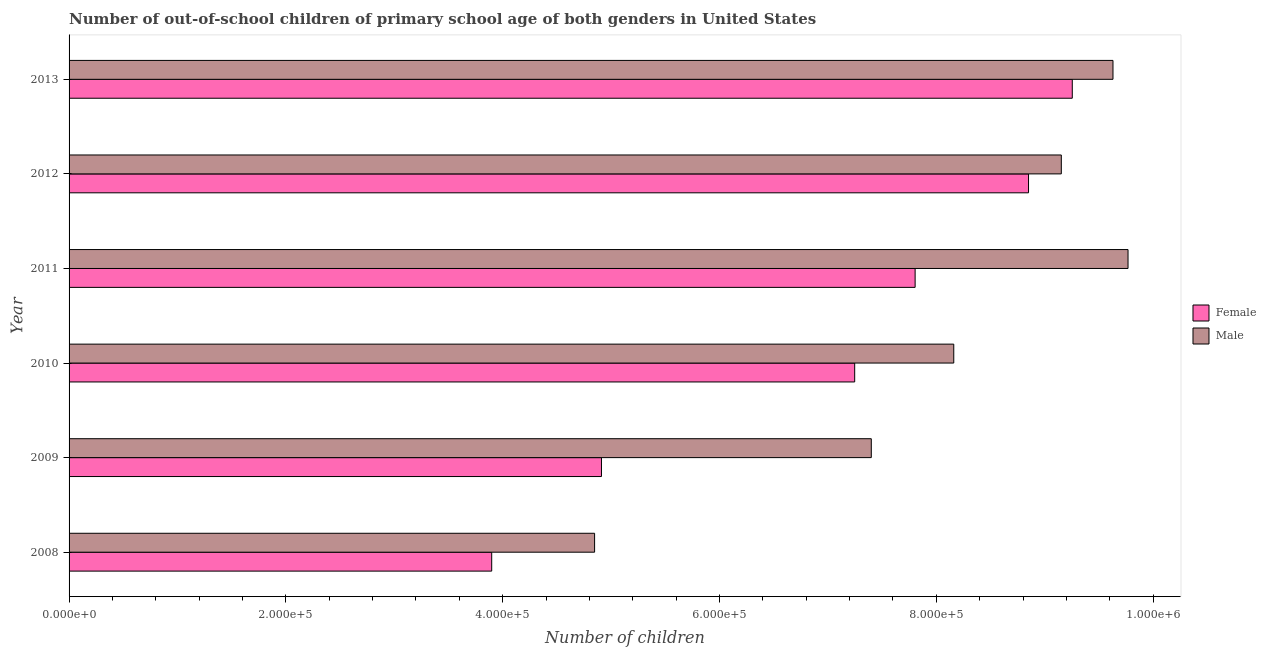How many different coloured bars are there?
Give a very brief answer. 2. How many groups of bars are there?
Ensure brevity in your answer.  6. Are the number of bars on each tick of the Y-axis equal?
Keep it short and to the point. Yes. How many bars are there on the 1st tick from the top?
Your answer should be very brief. 2. What is the number of male out-of-school students in 2013?
Offer a terse response. 9.63e+05. Across all years, what is the maximum number of female out-of-school students?
Your answer should be compact. 9.25e+05. Across all years, what is the minimum number of male out-of-school students?
Give a very brief answer. 4.85e+05. What is the total number of female out-of-school students in the graph?
Give a very brief answer. 4.20e+06. What is the difference between the number of male out-of-school students in 2011 and that in 2013?
Provide a succinct answer. 1.39e+04. What is the difference between the number of female out-of-school students in 2012 and the number of male out-of-school students in 2008?
Provide a succinct answer. 4.00e+05. What is the average number of female out-of-school students per year?
Offer a very short reply. 6.99e+05. In the year 2012, what is the difference between the number of female out-of-school students and number of male out-of-school students?
Make the answer very short. -3.02e+04. In how many years, is the number of female out-of-school students greater than 120000 ?
Give a very brief answer. 6. What is the ratio of the number of female out-of-school students in 2009 to that in 2012?
Provide a succinct answer. 0.56. Is the number of male out-of-school students in 2010 less than that in 2013?
Offer a very short reply. Yes. Is the difference between the number of female out-of-school students in 2008 and 2009 greater than the difference between the number of male out-of-school students in 2008 and 2009?
Ensure brevity in your answer.  Yes. What is the difference between the highest and the second highest number of male out-of-school students?
Keep it short and to the point. 1.39e+04. What is the difference between the highest and the lowest number of male out-of-school students?
Your response must be concise. 4.92e+05. What does the 1st bar from the top in 2010 represents?
Make the answer very short. Male. How many years are there in the graph?
Make the answer very short. 6. Does the graph contain any zero values?
Provide a short and direct response. No. How are the legend labels stacked?
Offer a terse response. Vertical. What is the title of the graph?
Provide a short and direct response. Number of out-of-school children of primary school age of both genders in United States. Does "Total Population" appear as one of the legend labels in the graph?
Make the answer very short. No. What is the label or title of the X-axis?
Offer a very short reply. Number of children. What is the Number of children of Female in 2008?
Offer a very short reply. 3.90e+05. What is the Number of children in Male in 2008?
Provide a short and direct response. 4.85e+05. What is the Number of children of Female in 2009?
Offer a terse response. 4.91e+05. What is the Number of children in Male in 2009?
Your answer should be very brief. 7.40e+05. What is the Number of children in Female in 2010?
Offer a very short reply. 7.25e+05. What is the Number of children of Male in 2010?
Ensure brevity in your answer.  8.16e+05. What is the Number of children of Female in 2011?
Give a very brief answer. 7.80e+05. What is the Number of children of Male in 2011?
Ensure brevity in your answer.  9.77e+05. What is the Number of children in Female in 2012?
Ensure brevity in your answer.  8.85e+05. What is the Number of children of Male in 2012?
Ensure brevity in your answer.  9.15e+05. What is the Number of children of Female in 2013?
Offer a very short reply. 9.25e+05. What is the Number of children of Male in 2013?
Keep it short and to the point. 9.63e+05. Across all years, what is the maximum Number of children in Female?
Offer a terse response. 9.25e+05. Across all years, what is the maximum Number of children in Male?
Offer a very short reply. 9.77e+05. Across all years, what is the minimum Number of children of Female?
Your answer should be compact. 3.90e+05. Across all years, what is the minimum Number of children of Male?
Offer a very short reply. 4.85e+05. What is the total Number of children in Female in the graph?
Your answer should be very brief. 4.20e+06. What is the total Number of children in Male in the graph?
Ensure brevity in your answer.  4.90e+06. What is the difference between the Number of children of Female in 2008 and that in 2009?
Keep it short and to the point. -1.01e+05. What is the difference between the Number of children of Male in 2008 and that in 2009?
Provide a succinct answer. -2.55e+05. What is the difference between the Number of children in Female in 2008 and that in 2010?
Your response must be concise. -3.35e+05. What is the difference between the Number of children of Male in 2008 and that in 2010?
Offer a terse response. -3.31e+05. What is the difference between the Number of children in Female in 2008 and that in 2011?
Your answer should be compact. -3.91e+05. What is the difference between the Number of children in Male in 2008 and that in 2011?
Give a very brief answer. -4.92e+05. What is the difference between the Number of children in Female in 2008 and that in 2012?
Your answer should be compact. -4.95e+05. What is the difference between the Number of children in Male in 2008 and that in 2012?
Your response must be concise. -4.31e+05. What is the difference between the Number of children in Female in 2008 and that in 2013?
Keep it short and to the point. -5.36e+05. What is the difference between the Number of children of Male in 2008 and that in 2013?
Ensure brevity in your answer.  -4.78e+05. What is the difference between the Number of children of Female in 2009 and that in 2010?
Provide a succinct answer. -2.34e+05. What is the difference between the Number of children in Male in 2009 and that in 2010?
Your answer should be compact. -7.61e+04. What is the difference between the Number of children of Female in 2009 and that in 2011?
Provide a succinct answer. -2.89e+05. What is the difference between the Number of children in Male in 2009 and that in 2011?
Keep it short and to the point. -2.37e+05. What is the difference between the Number of children of Female in 2009 and that in 2012?
Provide a succinct answer. -3.94e+05. What is the difference between the Number of children of Male in 2009 and that in 2012?
Provide a succinct answer. -1.75e+05. What is the difference between the Number of children in Female in 2009 and that in 2013?
Your answer should be compact. -4.34e+05. What is the difference between the Number of children in Male in 2009 and that in 2013?
Your response must be concise. -2.23e+05. What is the difference between the Number of children of Female in 2010 and that in 2011?
Offer a terse response. -5.58e+04. What is the difference between the Number of children of Male in 2010 and that in 2011?
Keep it short and to the point. -1.61e+05. What is the difference between the Number of children of Female in 2010 and that in 2012?
Your answer should be very brief. -1.60e+05. What is the difference between the Number of children in Male in 2010 and that in 2012?
Offer a very short reply. -9.92e+04. What is the difference between the Number of children of Female in 2010 and that in 2013?
Your answer should be compact. -2.01e+05. What is the difference between the Number of children of Male in 2010 and that in 2013?
Ensure brevity in your answer.  -1.47e+05. What is the difference between the Number of children in Female in 2011 and that in 2012?
Offer a terse response. -1.05e+05. What is the difference between the Number of children in Male in 2011 and that in 2012?
Keep it short and to the point. 6.15e+04. What is the difference between the Number of children of Female in 2011 and that in 2013?
Your response must be concise. -1.45e+05. What is the difference between the Number of children of Male in 2011 and that in 2013?
Keep it short and to the point. 1.39e+04. What is the difference between the Number of children of Female in 2012 and that in 2013?
Keep it short and to the point. -4.04e+04. What is the difference between the Number of children in Male in 2012 and that in 2013?
Your answer should be very brief. -4.77e+04. What is the difference between the Number of children of Female in 2008 and the Number of children of Male in 2009?
Your answer should be very brief. -3.50e+05. What is the difference between the Number of children of Female in 2008 and the Number of children of Male in 2010?
Provide a short and direct response. -4.26e+05. What is the difference between the Number of children in Female in 2008 and the Number of children in Male in 2011?
Offer a very short reply. -5.87e+05. What is the difference between the Number of children in Female in 2008 and the Number of children in Male in 2012?
Provide a succinct answer. -5.25e+05. What is the difference between the Number of children in Female in 2008 and the Number of children in Male in 2013?
Offer a very short reply. -5.73e+05. What is the difference between the Number of children in Female in 2009 and the Number of children in Male in 2010?
Keep it short and to the point. -3.25e+05. What is the difference between the Number of children in Female in 2009 and the Number of children in Male in 2011?
Your response must be concise. -4.86e+05. What is the difference between the Number of children of Female in 2009 and the Number of children of Male in 2012?
Offer a terse response. -4.24e+05. What is the difference between the Number of children of Female in 2009 and the Number of children of Male in 2013?
Keep it short and to the point. -4.72e+05. What is the difference between the Number of children in Female in 2010 and the Number of children in Male in 2011?
Keep it short and to the point. -2.52e+05. What is the difference between the Number of children of Female in 2010 and the Number of children of Male in 2012?
Make the answer very short. -1.91e+05. What is the difference between the Number of children in Female in 2010 and the Number of children in Male in 2013?
Keep it short and to the point. -2.38e+05. What is the difference between the Number of children in Female in 2011 and the Number of children in Male in 2012?
Offer a very short reply. -1.35e+05. What is the difference between the Number of children in Female in 2011 and the Number of children in Male in 2013?
Keep it short and to the point. -1.83e+05. What is the difference between the Number of children in Female in 2012 and the Number of children in Male in 2013?
Offer a very short reply. -7.79e+04. What is the average Number of children in Female per year?
Your response must be concise. 6.99e+05. What is the average Number of children of Male per year?
Your response must be concise. 8.16e+05. In the year 2008, what is the difference between the Number of children of Female and Number of children of Male?
Keep it short and to the point. -9.49e+04. In the year 2009, what is the difference between the Number of children in Female and Number of children in Male?
Make the answer very short. -2.49e+05. In the year 2010, what is the difference between the Number of children of Female and Number of children of Male?
Your answer should be compact. -9.14e+04. In the year 2011, what is the difference between the Number of children of Female and Number of children of Male?
Ensure brevity in your answer.  -1.96e+05. In the year 2012, what is the difference between the Number of children in Female and Number of children in Male?
Keep it short and to the point. -3.02e+04. In the year 2013, what is the difference between the Number of children of Female and Number of children of Male?
Your response must be concise. -3.75e+04. What is the ratio of the Number of children of Female in 2008 to that in 2009?
Provide a succinct answer. 0.79. What is the ratio of the Number of children of Male in 2008 to that in 2009?
Provide a short and direct response. 0.66. What is the ratio of the Number of children of Female in 2008 to that in 2010?
Keep it short and to the point. 0.54. What is the ratio of the Number of children in Male in 2008 to that in 2010?
Your answer should be compact. 0.59. What is the ratio of the Number of children in Female in 2008 to that in 2011?
Your answer should be compact. 0.5. What is the ratio of the Number of children in Male in 2008 to that in 2011?
Your answer should be compact. 0.5. What is the ratio of the Number of children of Female in 2008 to that in 2012?
Provide a short and direct response. 0.44. What is the ratio of the Number of children of Male in 2008 to that in 2012?
Your answer should be compact. 0.53. What is the ratio of the Number of children of Female in 2008 to that in 2013?
Ensure brevity in your answer.  0.42. What is the ratio of the Number of children of Male in 2008 to that in 2013?
Offer a terse response. 0.5. What is the ratio of the Number of children in Female in 2009 to that in 2010?
Your answer should be very brief. 0.68. What is the ratio of the Number of children in Male in 2009 to that in 2010?
Offer a terse response. 0.91. What is the ratio of the Number of children of Female in 2009 to that in 2011?
Offer a very short reply. 0.63. What is the ratio of the Number of children of Male in 2009 to that in 2011?
Your answer should be very brief. 0.76. What is the ratio of the Number of children in Female in 2009 to that in 2012?
Offer a terse response. 0.55. What is the ratio of the Number of children in Male in 2009 to that in 2012?
Your answer should be compact. 0.81. What is the ratio of the Number of children of Female in 2009 to that in 2013?
Offer a terse response. 0.53. What is the ratio of the Number of children in Male in 2009 to that in 2013?
Keep it short and to the point. 0.77. What is the ratio of the Number of children in Male in 2010 to that in 2011?
Provide a succinct answer. 0.84. What is the ratio of the Number of children in Female in 2010 to that in 2012?
Offer a terse response. 0.82. What is the ratio of the Number of children of Male in 2010 to that in 2012?
Offer a very short reply. 0.89. What is the ratio of the Number of children of Female in 2010 to that in 2013?
Provide a short and direct response. 0.78. What is the ratio of the Number of children of Male in 2010 to that in 2013?
Ensure brevity in your answer.  0.85. What is the ratio of the Number of children in Female in 2011 to that in 2012?
Offer a terse response. 0.88. What is the ratio of the Number of children of Male in 2011 to that in 2012?
Provide a short and direct response. 1.07. What is the ratio of the Number of children in Female in 2011 to that in 2013?
Ensure brevity in your answer.  0.84. What is the ratio of the Number of children in Male in 2011 to that in 2013?
Offer a terse response. 1.01. What is the ratio of the Number of children in Female in 2012 to that in 2013?
Offer a terse response. 0.96. What is the ratio of the Number of children in Male in 2012 to that in 2013?
Provide a succinct answer. 0.95. What is the difference between the highest and the second highest Number of children of Female?
Provide a short and direct response. 4.04e+04. What is the difference between the highest and the second highest Number of children of Male?
Ensure brevity in your answer.  1.39e+04. What is the difference between the highest and the lowest Number of children of Female?
Keep it short and to the point. 5.36e+05. What is the difference between the highest and the lowest Number of children in Male?
Your response must be concise. 4.92e+05. 